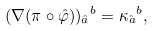<formula> <loc_0><loc_0><loc_500><loc_500>( \nabla ( \pi \circ \hat { \varphi } ) ) _ { \hat { a } } { ^ { b } } = \kappa _ { \hat { a } } { ^ { b } } ,</formula> 